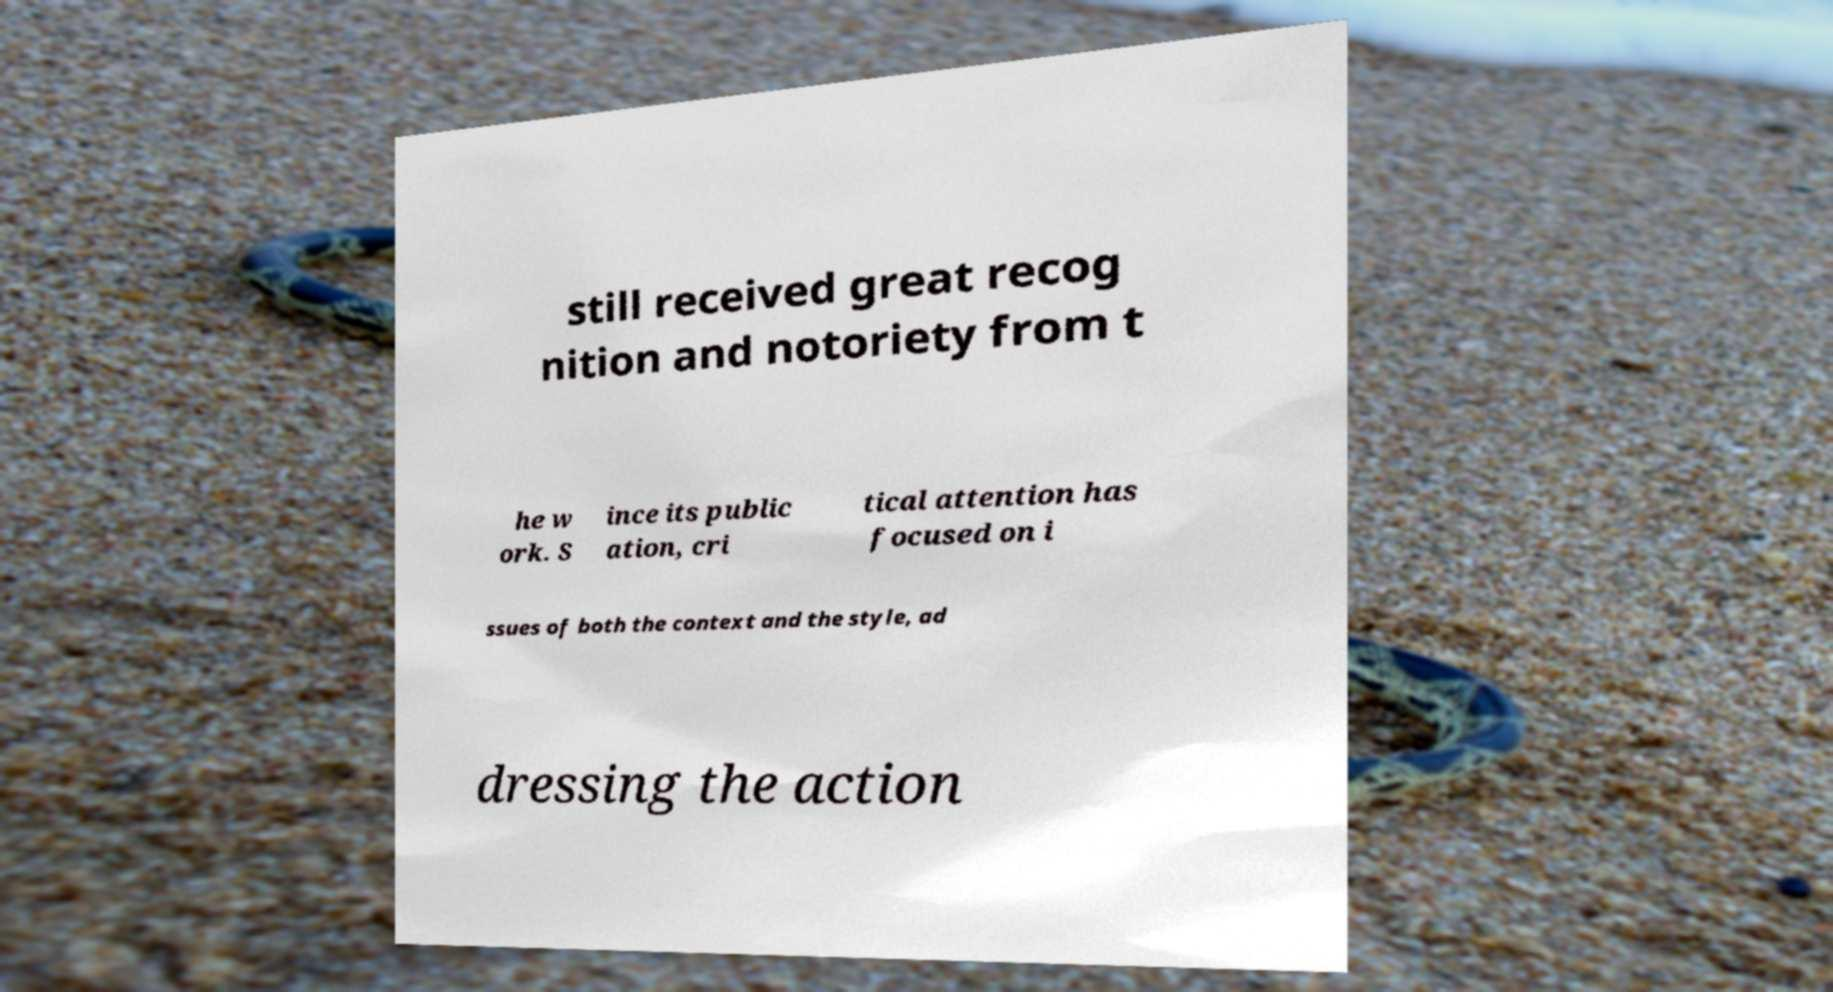For documentation purposes, I need the text within this image transcribed. Could you provide that? still received great recog nition and notoriety from t he w ork. S ince its public ation, cri tical attention has focused on i ssues of both the context and the style, ad dressing the action 